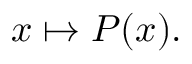<formula> <loc_0><loc_0><loc_500><loc_500>x \mapsto P ( x ) .</formula> 